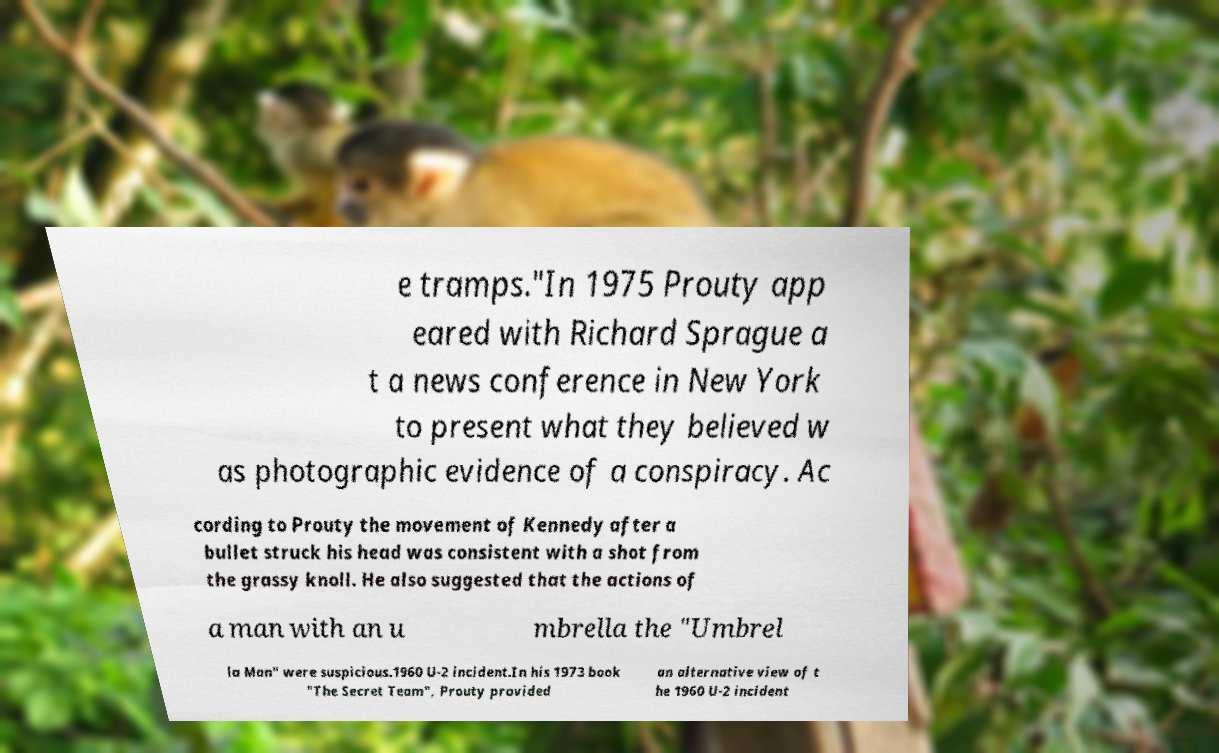For documentation purposes, I need the text within this image transcribed. Could you provide that? e tramps."In 1975 Prouty app eared with Richard Sprague a t a news conference in New York to present what they believed w as photographic evidence of a conspiracy. Ac cording to Prouty the movement of Kennedy after a bullet struck his head was consistent with a shot from the grassy knoll. He also suggested that the actions of a man with an u mbrella the "Umbrel la Man" were suspicious.1960 U-2 incident.In his 1973 book "The Secret Team", Prouty provided an alternative view of t he 1960 U-2 incident 